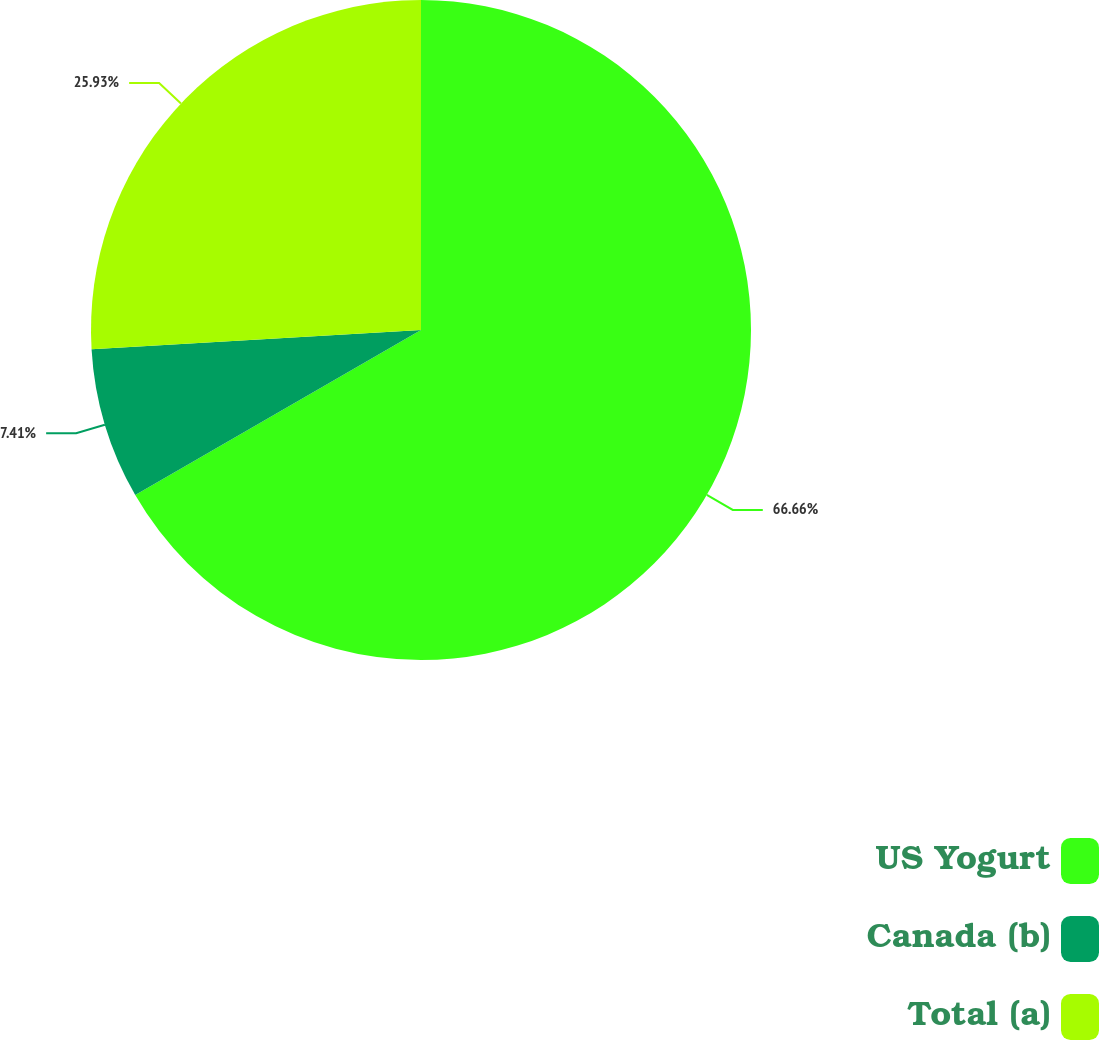Convert chart. <chart><loc_0><loc_0><loc_500><loc_500><pie_chart><fcel>US Yogurt<fcel>Canada (b)<fcel>Total (a)<nl><fcel>66.67%<fcel>7.41%<fcel>25.93%<nl></chart> 